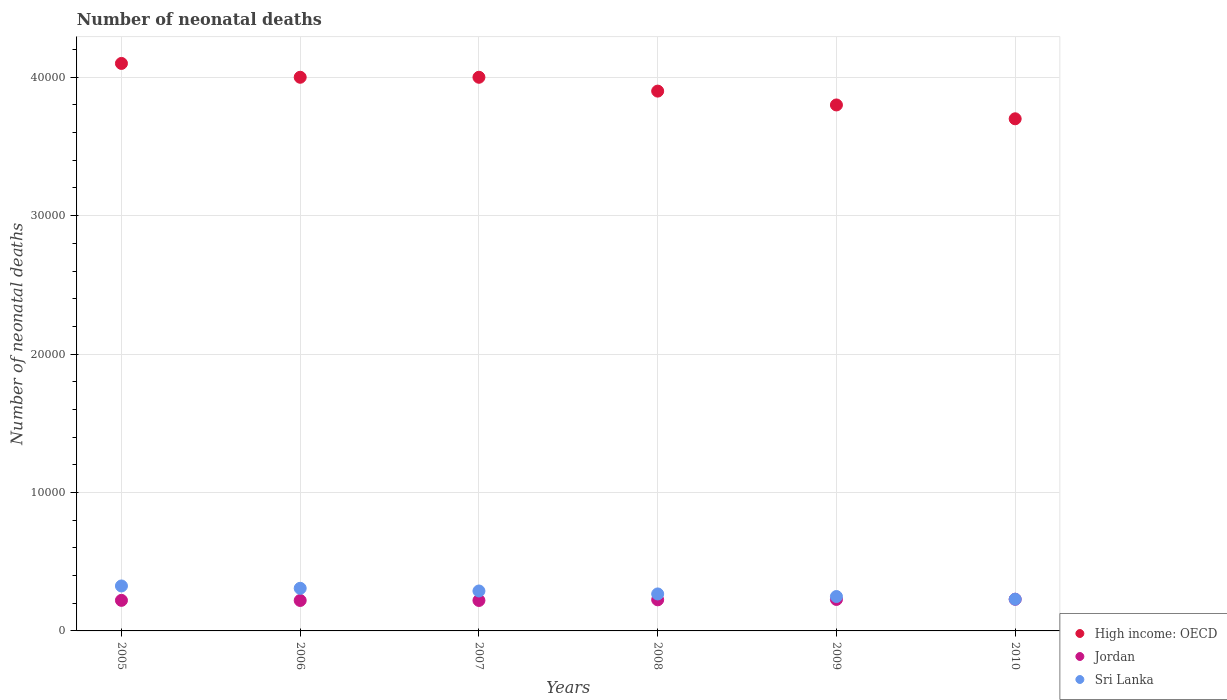How many different coloured dotlines are there?
Keep it short and to the point. 3. What is the number of neonatal deaths in in High income: OECD in 2008?
Provide a short and direct response. 3.90e+04. Across all years, what is the maximum number of neonatal deaths in in High income: OECD?
Make the answer very short. 4.10e+04. Across all years, what is the minimum number of neonatal deaths in in Sri Lanka?
Your response must be concise. 2292. In which year was the number of neonatal deaths in in Jordan maximum?
Provide a succinct answer. 2010. In which year was the number of neonatal deaths in in Jordan minimum?
Ensure brevity in your answer.  2006. What is the total number of neonatal deaths in in Jordan in the graph?
Keep it short and to the point. 1.34e+04. What is the difference between the number of neonatal deaths in in Sri Lanka in 2005 and that in 2006?
Provide a short and direct response. 169. What is the difference between the number of neonatal deaths in in Jordan in 2010 and the number of neonatal deaths in in Sri Lanka in 2009?
Your response must be concise. -197. What is the average number of neonatal deaths in in Jordan per year?
Give a very brief answer. 2236.33. In the year 2008, what is the difference between the number of neonatal deaths in in Sri Lanka and number of neonatal deaths in in Jordan?
Provide a succinct answer. 425. Is the difference between the number of neonatal deaths in in Sri Lanka in 2005 and 2007 greater than the difference between the number of neonatal deaths in in Jordan in 2005 and 2007?
Offer a terse response. Yes. What is the difference between the highest and the second highest number of neonatal deaths in in Sri Lanka?
Provide a short and direct response. 169. What is the difference between the highest and the lowest number of neonatal deaths in in High income: OECD?
Offer a terse response. 4000. In how many years, is the number of neonatal deaths in in Jordan greater than the average number of neonatal deaths in in Jordan taken over all years?
Provide a succinct answer. 3. Is the sum of the number of neonatal deaths in in Jordan in 2008 and 2009 greater than the maximum number of neonatal deaths in in Sri Lanka across all years?
Provide a succinct answer. Yes. Does the number of neonatal deaths in in Jordan monotonically increase over the years?
Give a very brief answer. No. Is the number of neonatal deaths in in Sri Lanka strictly greater than the number of neonatal deaths in in High income: OECD over the years?
Your answer should be compact. No. How many years are there in the graph?
Offer a very short reply. 6. Are the values on the major ticks of Y-axis written in scientific E-notation?
Your answer should be very brief. No. Does the graph contain any zero values?
Your answer should be compact. No. How many legend labels are there?
Keep it short and to the point. 3. What is the title of the graph?
Make the answer very short. Number of neonatal deaths. Does "Curacao" appear as one of the legend labels in the graph?
Your response must be concise. No. What is the label or title of the Y-axis?
Your answer should be very brief. Number of neonatal deaths. What is the Number of neonatal deaths in High income: OECD in 2005?
Keep it short and to the point. 4.10e+04. What is the Number of neonatal deaths of Jordan in 2005?
Ensure brevity in your answer.  2208. What is the Number of neonatal deaths of Sri Lanka in 2005?
Provide a short and direct response. 3248. What is the Number of neonatal deaths of High income: OECD in 2006?
Your answer should be very brief. 4.00e+04. What is the Number of neonatal deaths in Jordan in 2006?
Make the answer very short. 2200. What is the Number of neonatal deaths of Sri Lanka in 2006?
Provide a succinct answer. 3079. What is the Number of neonatal deaths of Jordan in 2007?
Make the answer very short. 2201. What is the Number of neonatal deaths in Sri Lanka in 2007?
Ensure brevity in your answer.  2885. What is the Number of neonatal deaths in High income: OECD in 2008?
Your answer should be compact. 3.90e+04. What is the Number of neonatal deaths in Jordan in 2008?
Make the answer very short. 2247. What is the Number of neonatal deaths in Sri Lanka in 2008?
Give a very brief answer. 2672. What is the Number of neonatal deaths in High income: OECD in 2009?
Make the answer very short. 3.80e+04. What is the Number of neonatal deaths of Jordan in 2009?
Provide a short and direct response. 2274. What is the Number of neonatal deaths in Sri Lanka in 2009?
Ensure brevity in your answer.  2485. What is the Number of neonatal deaths of High income: OECD in 2010?
Make the answer very short. 3.70e+04. What is the Number of neonatal deaths of Jordan in 2010?
Ensure brevity in your answer.  2288. What is the Number of neonatal deaths of Sri Lanka in 2010?
Give a very brief answer. 2292. Across all years, what is the maximum Number of neonatal deaths in High income: OECD?
Provide a short and direct response. 4.10e+04. Across all years, what is the maximum Number of neonatal deaths of Jordan?
Your answer should be very brief. 2288. Across all years, what is the maximum Number of neonatal deaths of Sri Lanka?
Make the answer very short. 3248. Across all years, what is the minimum Number of neonatal deaths in High income: OECD?
Offer a terse response. 3.70e+04. Across all years, what is the minimum Number of neonatal deaths of Jordan?
Offer a very short reply. 2200. Across all years, what is the minimum Number of neonatal deaths in Sri Lanka?
Ensure brevity in your answer.  2292. What is the total Number of neonatal deaths of High income: OECD in the graph?
Provide a succinct answer. 2.35e+05. What is the total Number of neonatal deaths in Jordan in the graph?
Your answer should be very brief. 1.34e+04. What is the total Number of neonatal deaths of Sri Lanka in the graph?
Offer a very short reply. 1.67e+04. What is the difference between the Number of neonatal deaths of High income: OECD in 2005 and that in 2006?
Keep it short and to the point. 1000. What is the difference between the Number of neonatal deaths of Jordan in 2005 and that in 2006?
Offer a very short reply. 8. What is the difference between the Number of neonatal deaths of Sri Lanka in 2005 and that in 2006?
Your answer should be very brief. 169. What is the difference between the Number of neonatal deaths in Sri Lanka in 2005 and that in 2007?
Your answer should be compact. 363. What is the difference between the Number of neonatal deaths in Jordan in 2005 and that in 2008?
Make the answer very short. -39. What is the difference between the Number of neonatal deaths in Sri Lanka in 2005 and that in 2008?
Your answer should be compact. 576. What is the difference between the Number of neonatal deaths in High income: OECD in 2005 and that in 2009?
Your answer should be very brief. 3000. What is the difference between the Number of neonatal deaths in Jordan in 2005 and that in 2009?
Make the answer very short. -66. What is the difference between the Number of neonatal deaths of Sri Lanka in 2005 and that in 2009?
Your response must be concise. 763. What is the difference between the Number of neonatal deaths of High income: OECD in 2005 and that in 2010?
Your answer should be very brief. 4000. What is the difference between the Number of neonatal deaths of Jordan in 2005 and that in 2010?
Keep it short and to the point. -80. What is the difference between the Number of neonatal deaths in Sri Lanka in 2005 and that in 2010?
Offer a very short reply. 956. What is the difference between the Number of neonatal deaths in High income: OECD in 2006 and that in 2007?
Offer a very short reply. 0. What is the difference between the Number of neonatal deaths of Jordan in 2006 and that in 2007?
Provide a short and direct response. -1. What is the difference between the Number of neonatal deaths in Sri Lanka in 2006 and that in 2007?
Offer a very short reply. 194. What is the difference between the Number of neonatal deaths in High income: OECD in 2006 and that in 2008?
Ensure brevity in your answer.  1000. What is the difference between the Number of neonatal deaths in Jordan in 2006 and that in 2008?
Give a very brief answer. -47. What is the difference between the Number of neonatal deaths of Sri Lanka in 2006 and that in 2008?
Give a very brief answer. 407. What is the difference between the Number of neonatal deaths of High income: OECD in 2006 and that in 2009?
Offer a terse response. 2000. What is the difference between the Number of neonatal deaths of Jordan in 2006 and that in 2009?
Offer a terse response. -74. What is the difference between the Number of neonatal deaths of Sri Lanka in 2006 and that in 2009?
Give a very brief answer. 594. What is the difference between the Number of neonatal deaths in High income: OECD in 2006 and that in 2010?
Provide a short and direct response. 3000. What is the difference between the Number of neonatal deaths in Jordan in 2006 and that in 2010?
Offer a terse response. -88. What is the difference between the Number of neonatal deaths of Sri Lanka in 2006 and that in 2010?
Make the answer very short. 787. What is the difference between the Number of neonatal deaths in Jordan in 2007 and that in 2008?
Your answer should be very brief. -46. What is the difference between the Number of neonatal deaths of Sri Lanka in 2007 and that in 2008?
Provide a succinct answer. 213. What is the difference between the Number of neonatal deaths in Jordan in 2007 and that in 2009?
Provide a short and direct response. -73. What is the difference between the Number of neonatal deaths in Sri Lanka in 2007 and that in 2009?
Your answer should be compact. 400. What is the difference between the Number of neonatal deaths in High income: OECD in 2007 and that in 2010?
Your answer should be compact. 3000. What is the difference between the Number of neonatal deaths in Jordan in 2007 and that in 2010?
Provide a succinct answer. -87. What is the difference between the Number of neonatal deaths in Sri Lanka in 2007 and that in 2010?
Make the answer very short. 593. What is the difference between the Number of neonatal deaths of High income: OECD in 2008 and that in 2009?
Offer a terse response. 1000. What is the difference between the Number of neonatal deaths in Sri Lanka in 2008 and that in 2009?
Keep it short and to the point. 187. What is the difference between the Number of neonatal deaths of High income: OECD in 2008 and that in 2010?
Keep it short and to the point. 2000. What is the difference between the Number of neonatal deaths in Jordan in 2008 and that in 2010?
Your response must be concise. -41. What is the difference between the Number of neonatal deaths of Sri Lanka in 2008 and that in 2010?
Your answer should be compact. 380. What is the difference between the Number of neonatal deaths of High income: OECD in 2009 and that in 2010?
Give a very brief answer. 1000. What is the difference between the Number of neonatal deaths in Jordan in 2009 and that in 2010?
Offer a terse response. -14. What is the difference between the Number of neonatal deaths in Sri Lanka in 2009 and that in 2010?
Keep it short and to the point. 193. What is the difference between the Number of neonatal deaths in High income: OECD in 2005 and the Number of neonatal deaths in Jordan in 2006?
Make the answer very short. 3.88e+04. What is the difference between the Number of neonatal deaths in High income: OECD in 2005 and the Number of neonatal deaths in Sri Lanka in 2006?
Provide a short and direct response. 3.79e+04. What is the difference between the Number of neonatal deaths in Jordan in 2005 and the Number of neonatal deaths in Sri Lanka in 2006?
Provide a short and direct response. -871. What is the difference between the Number of neonatal deaths of High income: OECD in 2005 and the Number of neonatal deaths of Jordan in 2007?
Your response must be concise. 3.88e+04. What is the difference between the Number of neonatal deaths of High income: OECD in 2005 and the Number of neonatal deaths of Sri Lanka in 2007?
Keep it short and to the point. 3.81e+04. What is the difference between the Number of neonatal deaths in Jordan in 2005 and the Number of neonatal deaths in Sri Lanka in 2007?
Make the answer very short. -677. What is the difference between the Number of neonatal deaths in High income: OECD in 2005 and the Number of neonatal deaths in Jordan in 2008?
Ensure brevity in your answer.  3.88e+04. What is the difference between the Number of neonatal deaths in High income: OECD in 2005 and the Number of neonatal deaths in Sri Lanka in 2008?
Your answer should be compact. 3.83e+04. What is the difference between the Number of neonatal deaths in Jordan in 2005 and the Number of neonatal deaths in Sri Lanka in 2008?
Keep it short and to the point. -464. What is the difference between the Number of neonatal deaths in High income: OECD in 2005 and the Number of neonatal deaths in Jordan in 2009?
Offer a terse response. 3.87e+04. What is the difference between the Number of neonatal deaths in High income: OECD in 2005 and the Number of neonatal deaths in Sri Lanka in 2009?
Make the answer very short. 3.85e+04. What is the difference between the Number of neonatal deaths of Jordan in 2005 and the Number of neonatal deaths of Sri Lanka in 2009?
Your response must be concise. -277. What is the difference between the Number of neonatal deaths in High income: OECD in 2005 and the Number of neonatal deaths in Jordan in 2010?
Your answer should be very brief. 3.87e+04. What is the difference between the Number of neonatal deaths in High income: OECD in 2005 and the Number of neonatal deaths in Sri Lanka in 2010?
Your answer should be compact. 3.87e+04. What is the difference between the Number of neonatal deaths of Jordan in 2005 and the Number of neonatal deaths of Sri Lanka in 2010?
Offer a very short reply. -84. What is the difference between the Number of neonatal deaths in High income: OECD in 2006 and the Number of neonatal deaths in Jordan in 2007?
Provide a short and direct response. 3.78e+04. What is the difference between the Number of neonatal deaths of High income: OECD in 2006 and the Number of neonatal deaths of Sri Lanka in 2007?
Provide a short and direct response. 3.71e+04. What is the difference between the Number of neonatal deaths of Jordan in 2006 and the Number of neonatal deaths of Sri Lanka in 2007?
Keep it short and to the point. -685. What is the difference between the Number of neonatal deaths of High income: OECD in 2006 and the Number of neonatal deaths of Jordan in 2008?
Offer a terse response. 3.78e+04. What is the difference between the Number of neonatal deaths in High income: OECD in 2006 and the Number of neonatal deaths in Sri Lanka in 2008?
Your response must be concise. 3.73e+04. What is the difference between the Number of neonatal deaths in Jordan in 2006 and the Number of neonatal deaths in Sri Lanka in 2008?
Offer a very short reply. -472. What is the difference between the Number of neonatal deaths of High income: OECD in 2006 and the Number of neonatal deaths of Jordan in 2009?
Your answer should be compact. 3.77e+04. What is the difference between the Number of neonatal deaths in High income: OECD in 2006 and the Number of neonatal deaths in Sri Lanka in 2009?
Keep it short and to the point. 3.75e+04. What is the difference between the Number of neonatal deaths of Jordan in 2006 and the Number of neonatal deaths of Sri Lanka in 2009?
Your response must be concise. -285. What is the difference between the Number of neonatal deaths of High income: OECD in 2006 and the Number of neonatal deaths of Jordan in 2010?
Ensure brevity in your answer.  3.77e+04. What is the difference between the Number of neonatal deaths in High income: OECD in 2006 and the Number of neonatal deaths in Sri Lanka in 2010?
Your answer should be very brief. 3.77e+04. What is the difference between the Number of neonatal deaths in Jordan in 2006 and the Number of neonatal deaths in Sri Lanka in 2010?
Offer a very short reply. -92. What is the difference between the Number of neonatal deaths in High income: OECD in 2007 and the Number of neonatal deaths in Jordan in 2008?
Offer a very short reply. 3.78e+04. What is the difference between the Number of neonatal deaths in High income: OECD in 2007 and the Number of neonatal deaths in Sri Lanka in 2008?
Give a very brief answer. 3.73e+04. What is the difference between the Number of neonatal deaths in Jordan in 2007 and the Number of neonatal deaths in Sri Lanka in 2008?
Give a very brief answer. -471. What is the difference between the Number of neonatal deaths in High income: OECD in 2007 and the Number of neonatal deaths in Jordan in 2009?
Your answer should be compact. 3.77e+04. What is the difference between the Number of neonatal deaths in High income: OECD in 2007 and the Number of neonatal deaths in Sri Lanka in 2009?
Offer a very short reply. 3.75e+04. What is the difference between the Number of neonatal deaths in Jordan in 2007 and the Number of neonatal deaths in Sri Lanka in 2009?
Give a very brief answer. -284. What is the difference between the Number of neonatal deaths of High income: OECD in 2007 and the Number of neonatal deaths of Jordan in 2010?
Make the answer very short. 3.77e+04. What is the difference between the Number of neonatal deaths in High income: OECD in 2007 and the Number of neonatal deaths in Sri Lanka in 2010?
Offer a terse response. 3.77e+04. What is the difference between the Number of neonatal deaths of Jordan in 2007 and the Number of neonatal deaths of Sri Lanka in 2010?
Provide a short and direct response. -91. What is the difference between the Number of neonatal deaths in High income: OECD in 2008 and the Number of neonatal deaths in Jordan in 2009?
Provide a short and direct response. 3.67e+04. What is the difference between the Number of neonatal deaths in High income: OECD in 2008 and the Number of neonatal deaths in Sri Lanka in 2009?
Give a very brief answer. 3.65e+04. What is the difference between the Number of neonatal deaths of Jordan in 2008 and the Number of neonatal deaths of Sri Lanka in 2009?
Your answer should be very brief. -238. What is the difference between the Number of neonatal deaths of High income: OECD in 2008 and the Number of neonatal deaths of Jordan in 2010?
Your answer should be very brief. 3.67e+04. What is the difference between the Number of neonatal deaths of High income: OECD in 2008 and the Number of neonatal deaths of Sri Lanka in 2010?
Provide a succinct answer. 3.67e+04. What is the difference between the Number of neonatal deaths of Jordan in 2008 and the Number of neonatal deaths of Sri Lanka in 2010?
Provide a short and direct response. -45. What is the difference between the Number of neonatal deaths of High income: OECD in 2009 and the Number of neonatal deaths of Jordan in 2010?
Make the answer very short. 3.57e+04. What is the difference between the Number of neonatal deaths of High income: OECD in 2009 and the Number of neonatal deaths of Sri Lanka in 2010?
Provide a short and direct response. 3.57e+04. What is the average Number of neonatal deaths of High income: OECD per year?
Ensure brevity in your answer.  3.92e+04. What is the average Number of neonatal deaths of Jordan per year?
Ensure brevity in your answer.  2236.33. What is the average Number of neonatal deaths of Sri Lanka per year?
Provide a succinct answer. 2776.83. In the year 2005, what is the difference between the Number of neonatal deaths in High income: OECD and Number of neonatal deaths in Jordan?
Provide a short and direct response. 3.88e+04. In the year 2005, what is the difference between the Number of neonatal deaths in High income: OECD and Number of neonatal deaths in Sri Lanka?
Keep it short and to the point. 3.78e+04. In the year 2005, what is the difference between the Number of neonatal deaths in Jordan and Number of neonatal deaths in Sri Lanka?
Your response must be concise. -1040. In the year 2006, what is the difference between the Number of neonatal deaths of High income: OECD and Number of neonatal deaths of Jordan?
Provide a succinct answer. 3.78e+04. In the year 2006, what is the difference between the Number of neonatal deaths in High income: OECD and Number of neonatal deaths in Sri Lanka?
Keep it short and to the point. 3.69e+04. In the year 2006, what is the difference between the Number of neonatal deaths in Jordan and Number of neonatal deaths in Sri Lanka?
Keep it short and to the point. -879. In the year 2007, what is the difference between the Number of neonatal deaths in High income: OECD and Number of neonatal deaths in Jordan?
Provide a succinct answer. 3.78e+04. In the year 2007, what is the difference between the Number of neonatal deaths of High income: OECD and Number of neonatal deaths of Sri Lanka?
Make the answer very short. 3.71e+04. In the year 2007, what is the difference between the Number of neonatal deaths of Jordan and Number of neonatal deaths of Sri Lanka?
Keep it short and to the point. -684. In the year 2008, what is the difference between the Number of neonatal deaths of High income: OECD and Number of neonatal deaths of Jordan?
Your answer should be compact. 3.68e+04. In the year 2008, what is the difference between the Number of neonatal deaths in High income: OECD and Number of neonatal deaths in Sri Lanka?
Provide a succinct answer. 3.63e+04. In the year 2008, what is the difference between the Number of neonatal deaths of Jordan and Number of neonatal deaths of Sri Lanka?
Provide a succinct answer. -425. In the year 2009, what is the difference between the Number of neonatal deaths of High income: OECD and Number of neonatal deaths of Jordan?
Your answer should be very brief. 3.57e+04. In the year 2009, what is the difference between the Number of neonatal deaths in High income: OECD and Number of neonatal deaths in Sri Lanka?
Ensure brevity in your answer.  3.55e+04. In the year 2009, what is the difference between the Number of neonatal deaths in Jordan and Number of neonatal deaths in Sri Lanka?
Provide a succinct answer. -211. In the year 2010, what is the difference between the Number of neonatal deaths of High income: OECD and Number of neonatal deaths of Jordan?
Give a very brief answer. 3.47e+04. In the year 2010, what is the difference between the Number of neonatal deaths of High income: OECD and Number of neonatal deaths of Sri Lanka?
Provide a succinct answer. 3.47e+04. What is the ratio of the Number of neonatal deaths of Jordan in 2005 to that in 2006?
Provide a short and direct response. 1. What is the ratio of the Number of neonatal deaths of Sri Lanka in 2005 to that in 2006?
Your answer should be very brief. 1.05. What is the ratio of the Number of neonatal deaths of Sri Lanka in 2005 to that in 2007?
Your answer should be very brief. 1.13. What is the ratio of the Number of neonatal deaths in High income: OECD in 2005 to that in 2008?
Offer a terse response. 1.05. What is the ratio of the Number of neonatal deaths in Jordan in 2005 to that in 2008?
Ensure brevity in your answer.  0.98. What is the ratio of the Number of neonatal deaths in Sri Lanka in 2005 to that in 2008?
Offer a very short reply. 1.22. What is the ratio of the Number of neonatal deaths in High income: OECD in 2005 to that in 2009?
Your response must be concise. 1.08. What is the ratio of the Number of neonatal deaths in Jordan in 2005 to that in 2009?
Provide a short and direct response. 0.97. What is the ratio of the Number of neonatal deaths in Sri Lanka in 2005 to that in 2009?
Your response must be concise. 1.31. What is the ratio of the Number of neonatal deaths in High income: OECD in 2005 to that in 2010?
Provide a short and direct response. 1.11. What is the ratio of the Number of neonatal deaths in Jordan in 2005 to that in 2010?
Keep it short and to the point. 0.96. What is the ratio of the Number of neonatal deaths in Sri Lanka in 2005 to that in 2010?
Your response must be concise. 1.42. What is the ratio of the Number of neonatal deaths in High income: OECD in 2006 to that in 2007?
Make the answer very short. 1. What is the ratio of the Number of neonatal deaths of Jordan in 2006 to that in 2007?
Ensure brevity in your answer.  1. What is the ratio of the Number of neonatal deaths of Sri Lanka in 2006 to that in 2007?
Make the answer very short. 1.07. What is the ratio of the Number of neonatal deaths in High income: OECD in 2006 to that in 2008?
Offer a very short reply. 1.03. What is the ratio of the Number of neonatal deaths in Jordan in 2006 to that in 2008?
Make the answer very short. 0.98. What is the ratio of the Number of neonatal deaths in Sri Lanka in 2006 to that in 2008?
Keep it short and to the point. 1.15. What is the ratio of the Number of neonatal deaths in High income: OECD in 2006 to that in 2009?
Give a very brief answer. 1.05. What is the ratio of the Number of neonatal deaths of Jordan in 2006 to that in 2009?
Your response must be concise. 0.97. What is the ratio of the Number of neonatal deaths in Sri Lanka in 2006 to that in 2009?
Ensure brevity in your answer.  1.24. What is the ratio of the Number of neonatal deaths of High income: OECD in 2006 to that in 2010?
Keep it short and to the point. 1.08. What is the ratio of the Number of neonatal deaths of Jordan in 2006 to that in 2010?
Offer a very short reply. 0.96. What is the ratio of the Number of neonatal deaths of Sri Lanka in 2006 to that in 2010?
Your response must be concise. 1.34. What is the ratio of the Number of neonatal deaths in High income: OECD in 2007 to that in 2008?
Give a very brief answer. 1.03. What is the ratio of the Number of neonatal deaths in Jordan in 2007 to that in 2008?
Offer a terse response. 0.98. What is the ratio of the Number of neonatal deaths in Sri Lanka in 2007 to that in 2008?
Offer a terse response. 1.08. What is the ratio of the Number of neonatal deaths of High income: OECD in 2007 to that in 2009?
Your answer should be compact. 1.05. What is the ratio of the Number of neonatal deaths in Jordan in 2007 to that in 2009?
Make the answer very short. 0.97. What is the ratio of the Number of neonatal deaths in Sri Lanka in 2007 to that in 2009?
Ensure brevity in your answer.  1.16. What is the ratio of the Number of neonatal deaths of High income: OECD in 2007 to that in 2010?
Ensure brevity in your answer.  1.08. What is the ratio of the Number of neonatal deaths in Jordan in 2007 to that in 2010?
Provide a short and direct response. 0.96. What is the ratio of the Number of neonatal deaths of Sri Lanka in 2007 to that in 2010?
Offer a very short reply. 1.26. What is the ratio of the Number of neonatal deaths in High income: OECD in 2008 to that in 2009?
Provide a short and direct response. 1.03. What is the ratio of the Number of neonatal deaths in Sri Lanka in 2008 to that in 2009?
Your answer should be very brief. 1.08. What is the ratio of the Number of neonatal deaths in High income: OECD in 2008 to that in 2010?
Give a very brief answer. 1.05. What is the ratio of the Number of neonatal deaths in Jordan in 2008 to that in 2010?
Ensure brevity in your answer.  0.98. What is the ratio of the Number of neonatal deaths of Sri Lanka in 2008 to that in 2010?
Make the answer very short. 1.17. What is the ratio of the Number of neonatal deaths of High income: OECD in 2009 to that in 2010?
Your answer should be compact. 1.03. What is the ratio of the Number of neonatal deaths of Jordan in 2009 to that in 2010?
Give a very brief answer. 0.99. What is the ratio of the Number of neonatal deaths of Sri Lanka in 2009 to that in 2010?
Ensure brevity in your answer.  1.08. What is the difference between the highest and the second highest Number of neonatal deaths of High income: OECD?
Make the answer very short. 1000. What is the difference between the highest and the second highest Number of neonatal deaths of Sri Lanka?
Give a very brief answer. 169. What is the difference between the highest and the lowest Number of neonatal deaths of High income: OECD?
Offer a very short reply. 4000. What is the difference between the highest and the lowest Number of neonatal deaths in Sri Lanka?
Give a very brief answer. 956. 